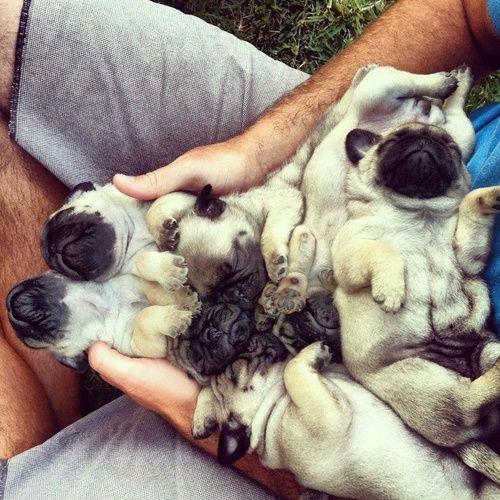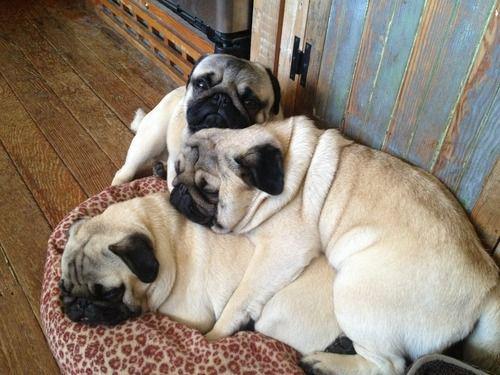The first image is the image on the left, the second image is the image on the right. Examine the images to the left and right. Is the description "there are no more than three puppies in the image on the left." accurate? Answer yes or no. No. The first image is the image on the left, the second image is the image on the right. Evaluate the accuracy of this statement regarding the images: "There are more pug dogs in the right image than in the left.". Is it true? Answer yes or no. No. 